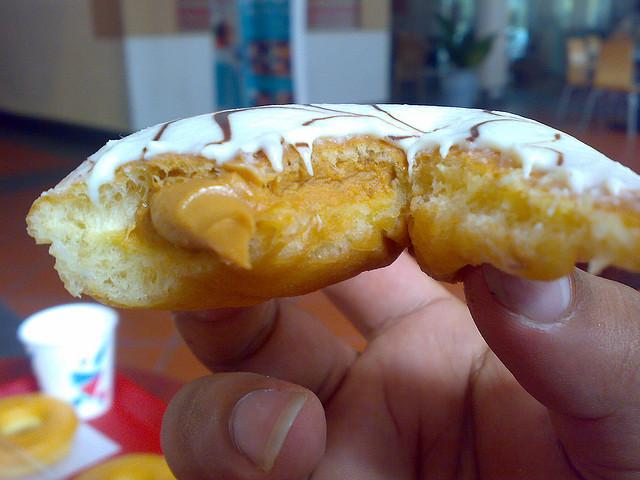What is under the doughnut?
Write a very short answer. Hand. Are the fingernails long or short?
Short answer required. Short. What meal is this served for?
Write a very short answer. Breakfast. Does this food have filling?
Keep it brief. Yes. What kind of food is this?
Write a very short answer. Donut. Which hand is that?
Be succinct. Right. What finger is showing?
Give a very brief answer. Ring. 